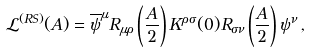<formula> <loc_0><loc_0><loc_500><loc_500>\mathcal { L } ^ { ( R S ) } ( A ) = \overline { \psi } ^ { \mu } R _ { \mu \rho } \left ( \frac { A } { 2 } \right ) K ^ { \rho \sigma } ( 0 ) R _ { \sigma \nu } \left ( \frac { A } { 2 } \right ) \psi ^ { \nu } \, ,</formula> 